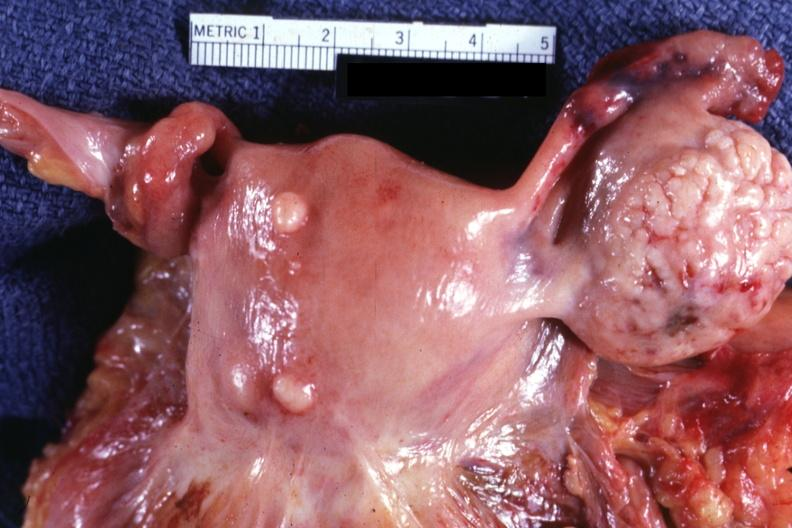s normal ovary in photo?
Answer the question using a single word or phrase. Yes 